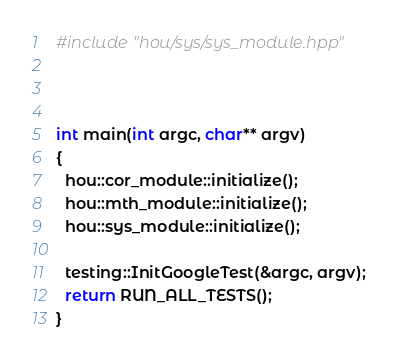Convert code to text. <code><loc_0><loc_0><loc_500><loc_500><_C++_>#include "hou/sys/sys_module.hpp"



int main(int argc, char** argv)
{
  hou::cor_module::initialize();
  hou::mth_module::initialize();
  hou::sys_module::initialize();

  testing::InitGoogleTest(&argc, argv);
  return RUN_ALL_TESTS();
}
</code> 